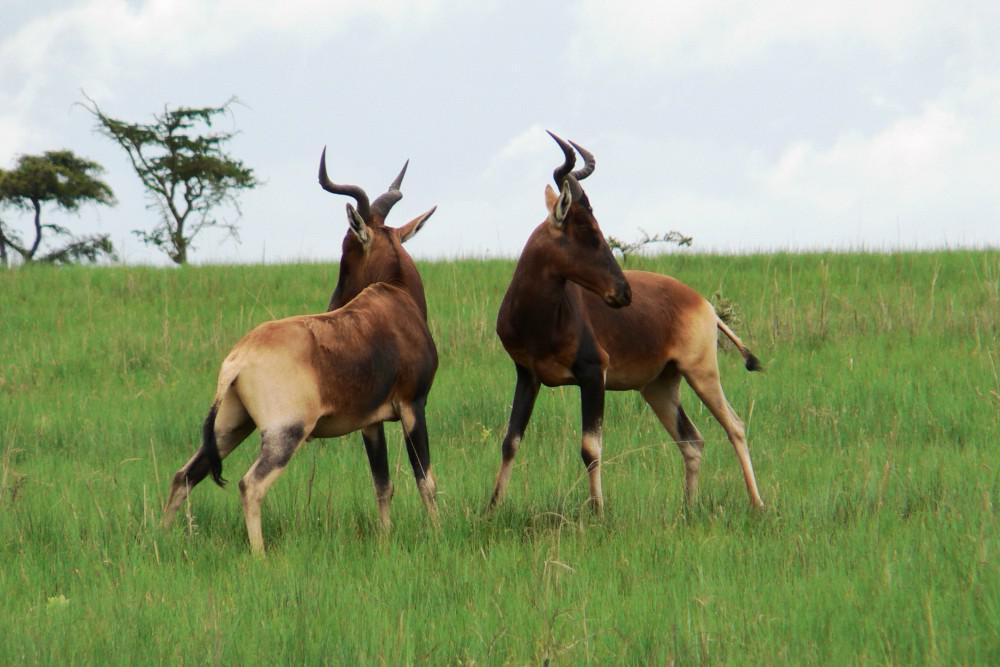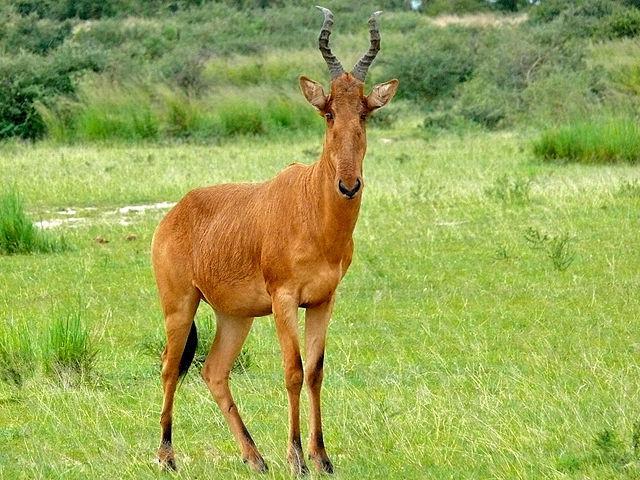The first image is the image on the left, the second image is the image on the right. Assess this claim about the two images: "A total of three horned animals are shown in grassy areas.". Correct or not? Answer yes or no. Yes. 